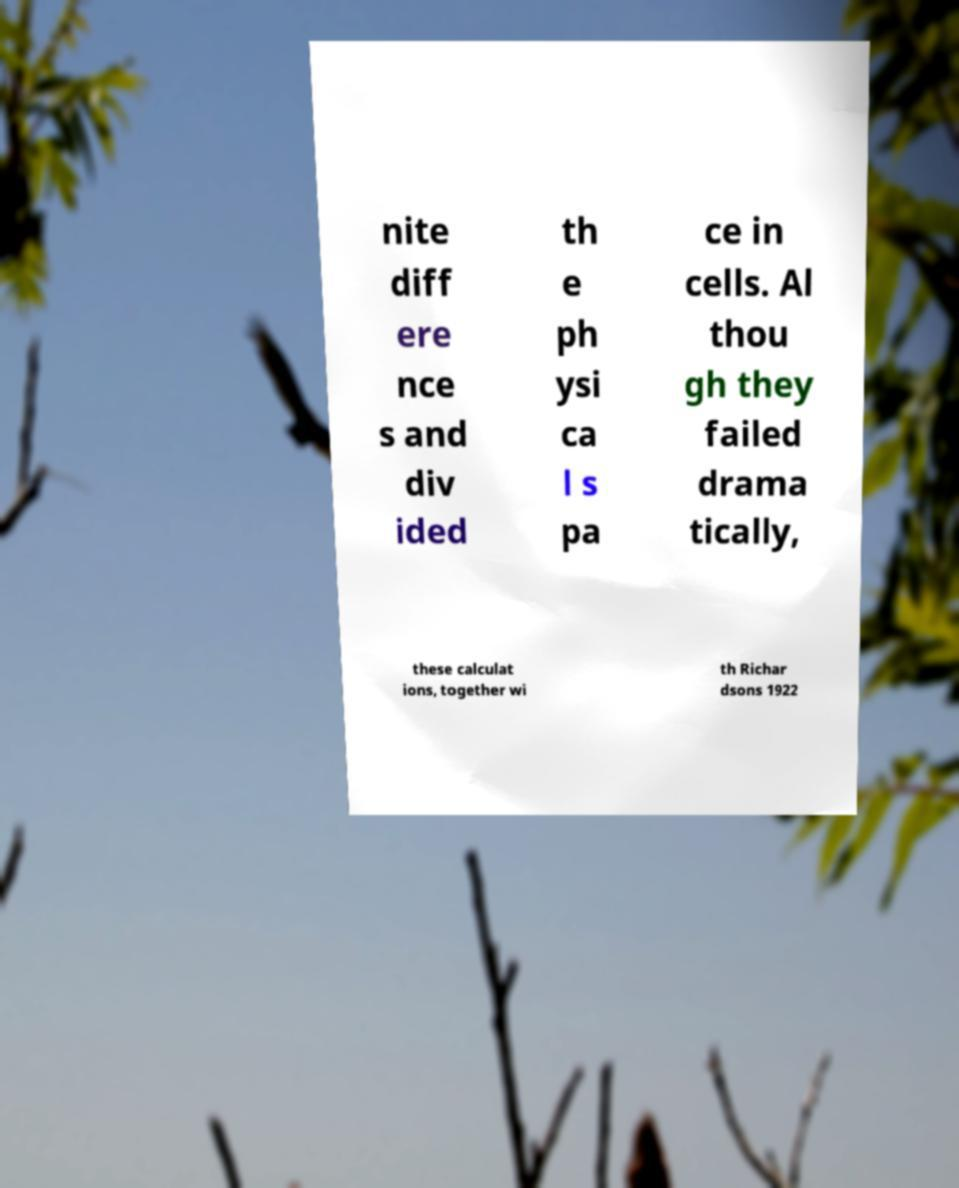Please identify and transcribe the text found in this image. nite diff ere nce s and div ided th e ph ysi ca l s pa ce in cells. Al thou gh they failed drama tically, these calculat ions, together wi th Richar dsons 1922 